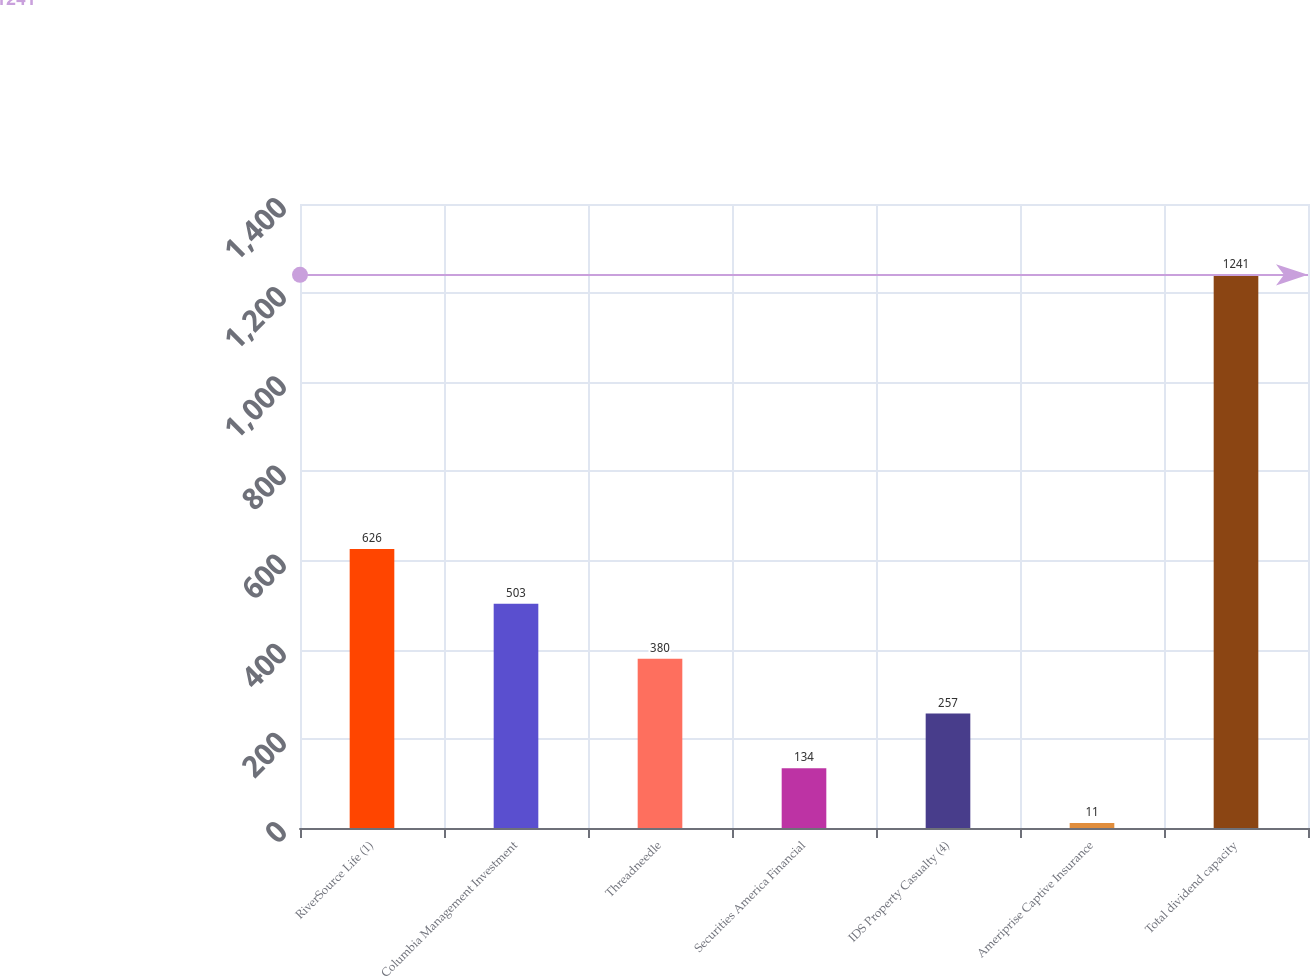Convert chart to OTSL. <chart><loc_0><loc_0><loc_500><loc_500><bar_chart><fcel>RiverSource Life (1)<fcel>Columbia Management Investment<fcel>Threadneedle<fcel>Securities America Financial<fcel>IDS Property Casualty (4)<fcel>Ameriprise Captive Insurance<fcel>Total dividend capacity<nl><fcel>626<fcel>503<fcel>380<fcel>134<fcel>257<fcel>11<fcel>1241<nl></chart> 